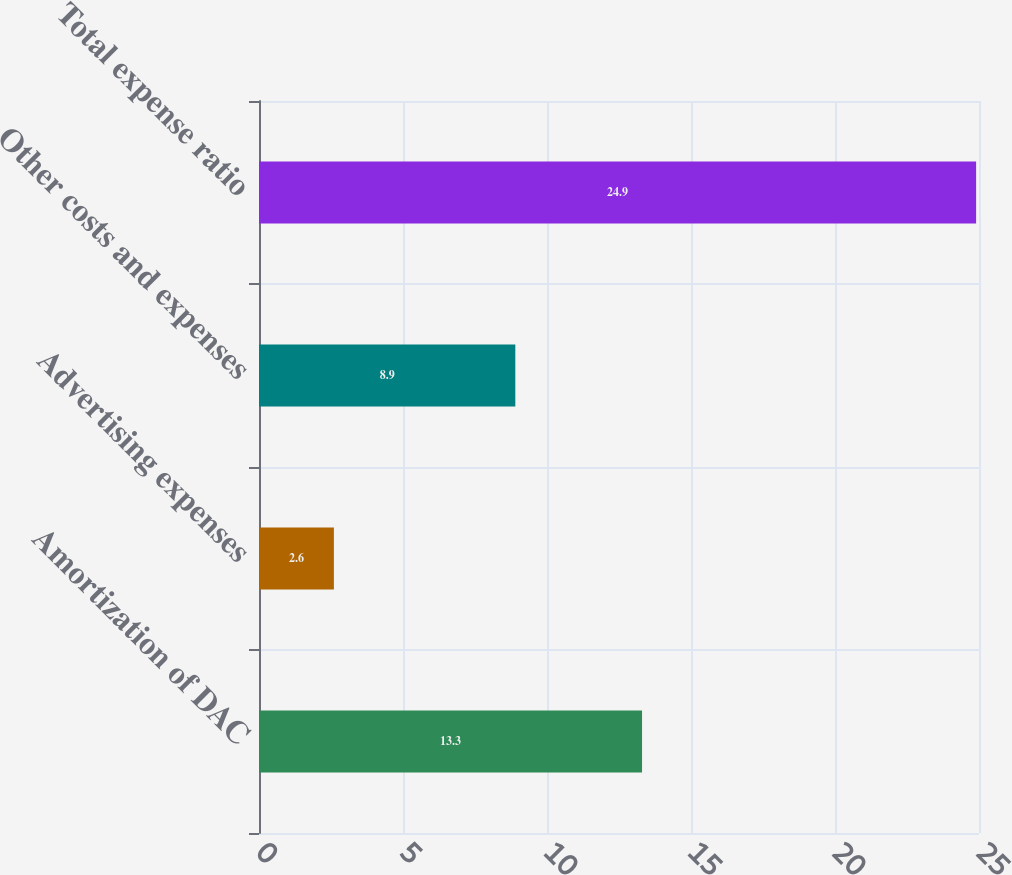Convert chart to OTSL. <chart><loc_0><loc_0><loc_500><loc_500><bar_chart><fcel>Amortization of DAC<fcel>Advertising expenses<fcel>Other costs and expenses<fcel>Total expense ratio<nl><fcel>13.3<fcel>2.6<fcel>8.9<fcel>24.9<nl></chart> 